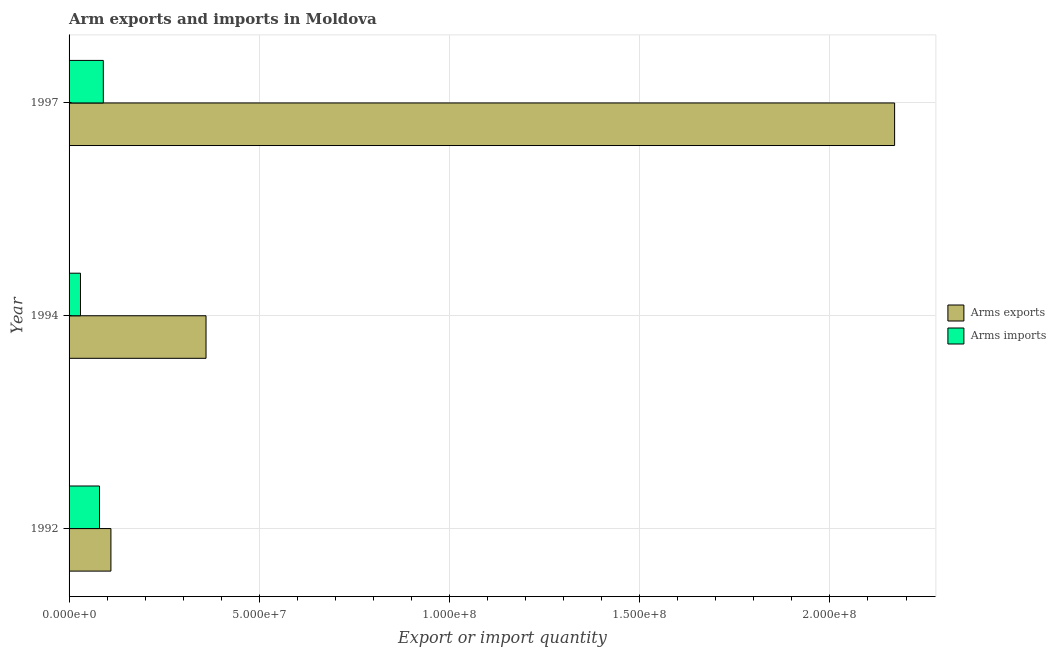How many groups of bars are there?
Offer a very short reply. 3. Are the number of bars per tick equal to the number of legend labels?
Make the answer very short. Yes. Are the number of bars on each tick of the Y-axis equal?
Your response must be concise. Yes. What is the label of the 1st group of bars from the top?
Offer a very short reply. 1997. What is the arms imports in 1997?
Keep it short and to the point. 9.00e+06. Across all years, what is the maximum arms imports?
Offer a very short reply. 9.00e+06. Across all years, what is the minimum arms imports?
Provide a short and direct response. 3.00e+06. In which year was the arms imports maximum?
Your answer should be compact. 1997. In which year was the arms imports minimum?
Your answer should be very brief. 1994. What is the total arms exports in the graph?
Offer a very short reply. 2.64e+08. What is the difference between the arms imports in 1992 and that in 1997?
Provide a short and direct response. -1.00e+06. What is the difference between the arms imports in 1992 and the arms exports in 1997?
Offer a very short reply. -2.09e+08. What is the average arms imports per year?
Ensure brevity in your answer.  6.67e+06. In the year 1992, what is the difference between the arms imports and arms exports?
Offer a very short reply. -3.00e+06. What is the ratio of the arms imports in 1994 to that in 1997?
Ensure brevity in your answer.  0.33. Is the arms exports in 1992 less than that in 1997?
Give a very brief answer. Yes. Is the difference between the arms imports in 1994 and 1997 greater than the difference between the arms exports in 1994 and 1997?
Provide a succinct answer. Yes. What is the difference between the highest and the lowest arms exports?
Your answer should be compact. 2.06e+08. What does the 2nd bar from the top in 1997 represents?
Offer a terse response. Arms exports. What does the 2nd bar from the bottom in 1994 represents?
Provide a short and direct response. Arms imports. Are all the bars in the graph horizontal?
Your answer should be compact. Yes. Are the values on the major ticks of X-axis written in scientific E-notation?
Your response must be concise. Yes. Does the graph contain grids?
Ensure brevity in your answer.  Yes. Where does the legend appear in the graph?
Your answer should be compact. Center right. How many legend labels are there?
Provide a short and direct response. 2. What is the title of the graph?
Provide a short and direct response. Arm exports and imports in Moldova. Does "Attending school" appear as one of the legend labels in the graph?
Your answer should be compact. No. What is the label or title of the X-axis?
Offer a very short reply. Export or import quantity. What is the label or title of the Y-axis?
Your answer should be compact. Year. What is the Export or import quantity of Arms exports in 1992?
Ensure brevity in your answer.  1.10e+07. What is the Export or import quantity of Arms exports in 1994?
Provide a succinct answer. 3.60e+07. What is the Export or import quantity in Arms imports in 1994?
Make the answer very short. 3.00e+06. What is the Export or import quantity of Arms exports in 1997?
Your answer should be compact. 2.17e+08. What is the Export or import quantity of Arms imports in 1997?
Your answer should be very brief. 9.00e+06. Across all years, what is the maximum Export or import quantity in Arms exports?
Your answer should be compact. 2.17e+08. Across all years, what is the maximum Export or import quantity in Arms imports?
Your answer should be very brief. 9.00e+06. Across all years, what is the minimum Export or import quantity of Arms exports?
Provide a succinct answer. 1.10e+07. What is the total Export or import quantity in Arms exports in the graph?
Offer a terse response. 2.64e+08. What is the difference between the Export or import quantity in Arms exports in 1992 and that in 1994?
Provide a short and direct response. -2.50e+07. What is the difference between the Export or import quantity of Arms imports in 1992 and that in 1994?
Provide a succinct answer. 5.00e+06. What is the difference between the Export or import quantity in Arms exports in 1992 and that in 1997?
Offer a terse response. -2.06e+08. What is the difference between the Export or import quantity of Arms exports in 1994 and that in 1997?
Give a very brief answer. -1.81e+08. What is the difference between the Export or import quantity of Arms imports in 1994 and that in 1997?
Offer a very short reply. -6.00e+06. What is the difference between the Export or import quantity in Arms exports in 1992 and the Export or import quantity in Arms imports in 1994?
Give a very brief answer. 8.00e+06. What is the difference between the Export or import quantity of Arms exports in 1994 and the Export or import quantity of Arms imports in 1997?
Make the answer very short. 2.70e+07. What is the average Export or import quantity of Arms exports per year?
Keep it short and to the point. 8.80e+07. What is the average Export or import quantity in Arms imports per year?
Ensure brevity in your answer.  6.67e+06. In the year 1994, what is the difference between the Export or import quantity in Arms exports and Export or import quantity in Arms imports?
Make the answer very short. 3.30e+07. In the year 1997, what is the difference between the Export or import quantity of Arms exports and Export or import quantity of Arms imports?
Provide a short and direct response. 2.08e+08. What is the ratio of the Export or import quantity of Arms exports in 1992 to that in 1994?
Keep it short and to the point. 0.31. What is the ratio of the Export or import quantity in Arms imports in 1992 to that in 1994?
Provide a short and direct response. 2.67. What is the ratio of the Export or import quantity of Arms exports in 1992 to that in 1997?
Make the answer very short. 0.05. What is the ratio of the Export or import quantity in Arms imports in 1992 to that in 1997?
Offer a terse response. 0.89. What is the ratio of the Export or import quantity in Arms exports in 1994 to that in 1997?
Give a very brief answer. 0.17. What is the ratio of the Export or import quantity of Arms imports in 1994 to that in 1997?
Provide a succinct answer. 0.33. What is the difference between the highest and the second highest Export or import quantity of Arms exports?
Ensure brevity in your answer.  1.81e+08. What is the difference between the highest and the lowest Export or import quantity of Arms exports?
Ensure brevity in your answer.  2.06e+08. What is the difference between the highest and the lowest Export or import quantity of Arms imports?
Your answer should be compact. 6.00e+06. 